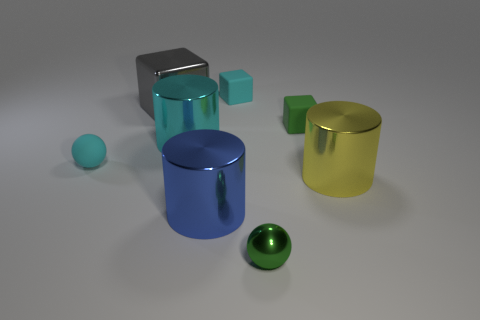Add 2 small green shiny balls. How many objects exist? 10 Subtract 1 cylinders. How many cylinders are left? 2 Subtract all rubber cubes. How many cubes are left? 1 Subtract all cubes. How many objects are left? 5 Subtract all green spheres. How many spheres are left? 1 Subtract all blue cubes. How many purple cylinders are left? 0 Subtract all small metallic spheres. Subtract all yellow cylinders. How many objects are left? 6 Add 5 small metal things. How many small metal things are left? 6 Add 4 large green metallic cubes. How many large green metallic cubes exist? 4 Subtract 0 red cylinders. How many objects are left? 8 